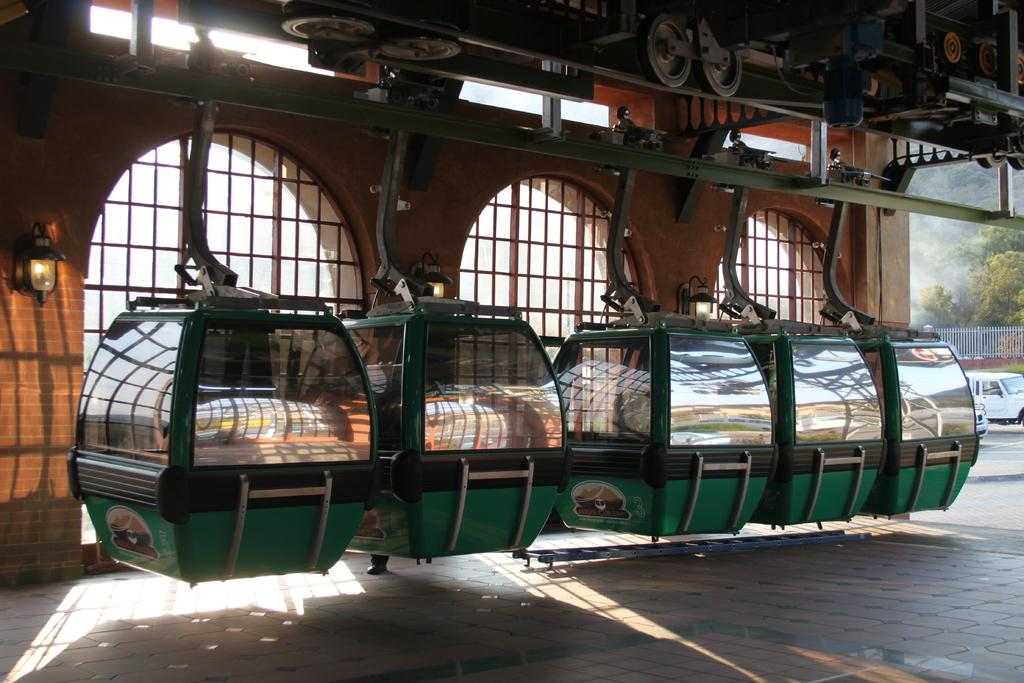What type of transportation system is depicted in the image? There are ropeways in the image, which is a type of transportation system. What structures support the ropeways? There are poles in the image that support the ropeways. What mechanical components are present in the image? Mechanical instruments are present in the image, which are likely used to operate the ropeways. What type of wheels can be seen in the image? Wheels are visible in the image, which are likely part of the vehicle or mechanical instruments. What can be seen through the windows in the image? There are windows in the image, but it is not clear what can be seen through them without more context. What type of lighting is present in the image? Lights are present in the image, which may be used to illuminate the area or signal the ropeway's operation. What type of vegetation is visible in the image? Trees are visible in the image, which suggests that the ropeway is located in a natural or semi-natural environment. What type of vehicle is present in the image? There is a vehicle in the image, but it is not clear what type of vehicle it is without more context. What type of barrier is present in the image? There is a wall in the image, which may serve as a barrier or boundary. What class of animals can be observed in the image? There is no mention of any animals in the image, so it is not possible to determine the class of animals that might be present. 